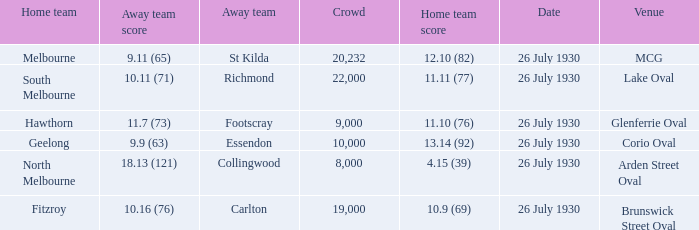When was Fitzroy the home team? 26 July 1930. 